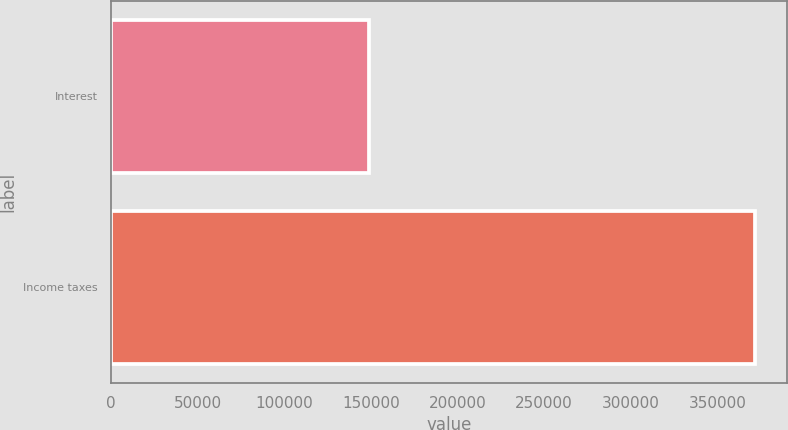Convert chart to OTSL. <chart><loc_0><loc_0><loc_500><loc_500><bar_chart><fcel>Interest<fcel>Income taxes<nl><fcel>148654<fcel>371547<nl></chart> 